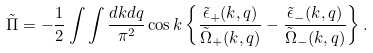Convert formula to latex. <formula><loc_0><loc_0><loc_500><loc_500>\tilde { \Pi } = - \frac { 1 } { 2 } \int \int \frac { d k d q } { \pi ^ { 2 } } \cos { k } \left \{ \frac { \tilde { \epsilon } _ { + } ( k , q ) } { \tilde { \Omega } _ { + } ( k , q ) } - \frac { \tilde { \epsilon } _ { - } ( k , q ) } { \tilde { \Omega } _ { - } ( k , q ) } \right \} .</formula> 